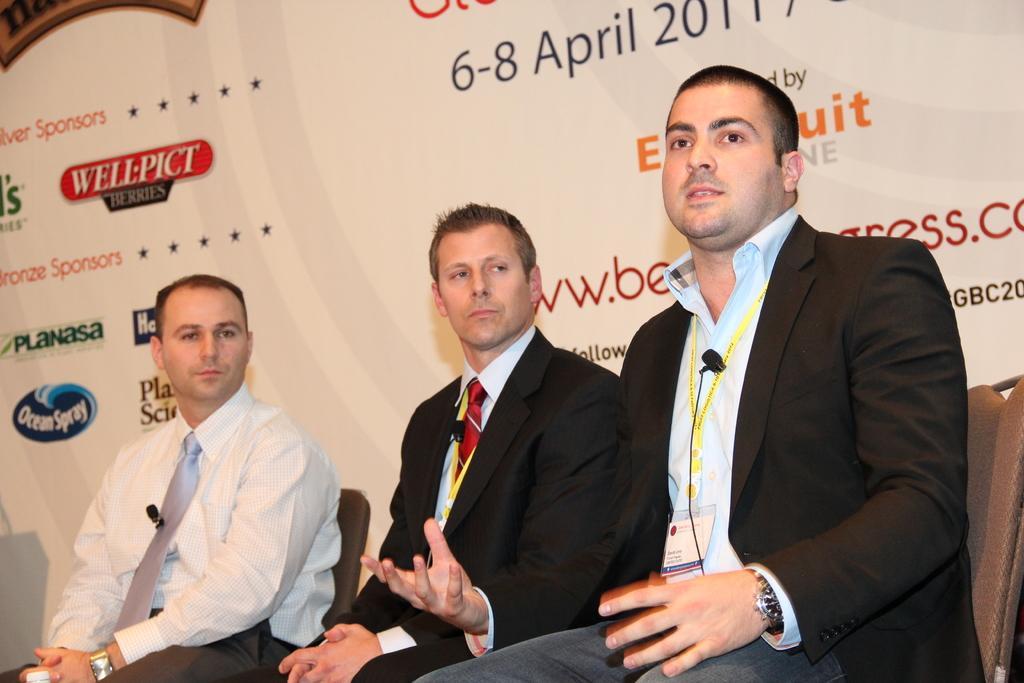In one or two sentences, can you explain what this image depicts? In the center of the picture we can few people sitting on chairs. On the right the person is talking. In the background there is a banner. 